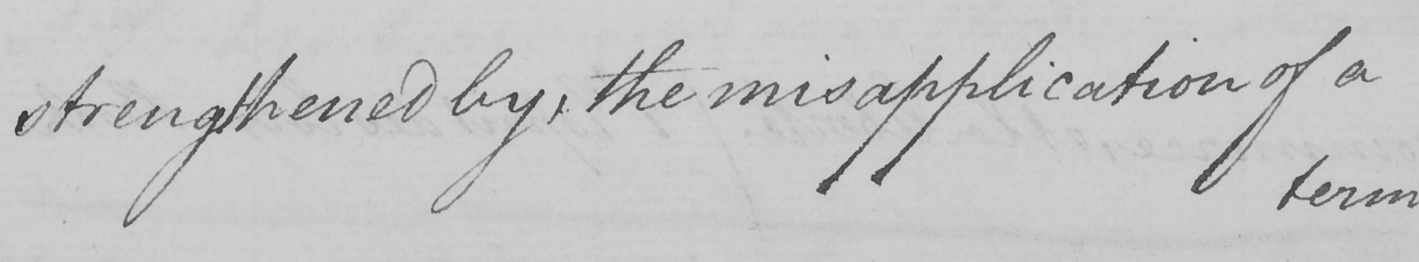Please transcribe the handwritten text in this image. strengthened by , the misapplication of a 